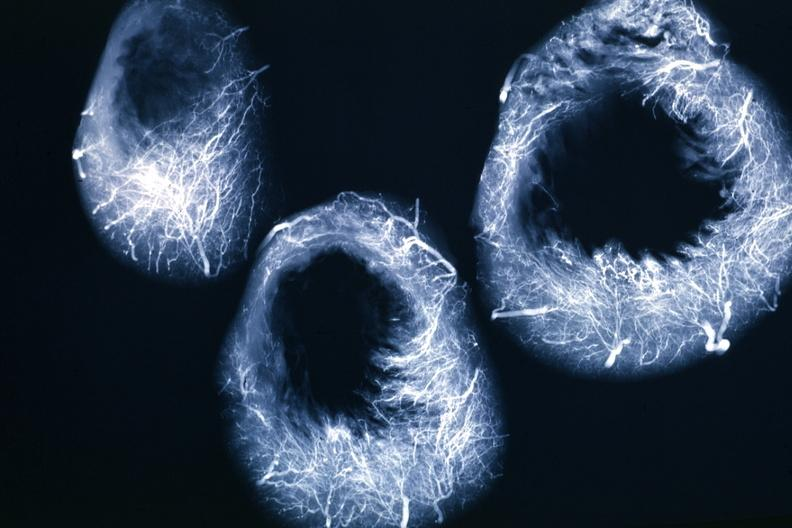does lymphangiomatosis generalized show x-ray horizontal sections of ventricle showing penetrating artery distribution quite good?
Answer the question using a single word or phrase. No 